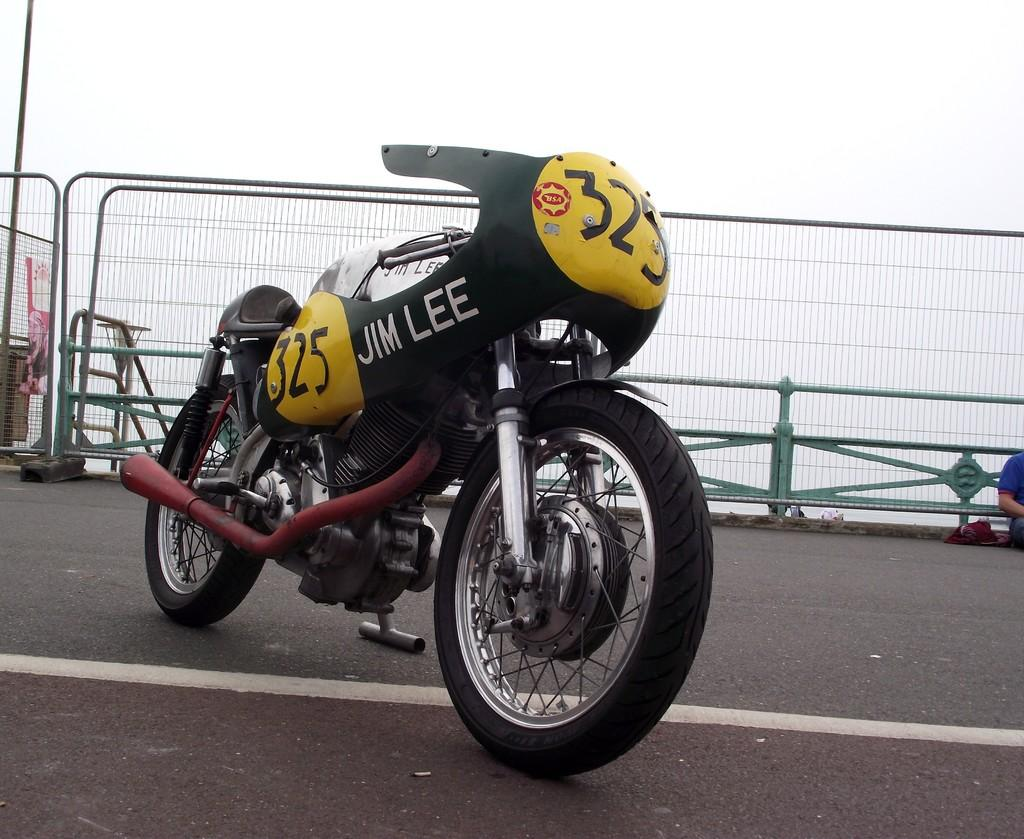What is the main subject of the image? The main subject of the image is a motorbike on the road. What can be seen in the background of the image? There is a fence visible in the background of the image. Can you describe the person in the image? There is a person on the right side of the image. What type of flame can be seen coming from the exhaust of the motorbike in the image? There is no flame coming from the exhaust of the motorbike in the image. Are there any slaves depicted in the image? There is no reference to slavery or slaves in the image. 